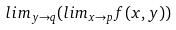<formula> <loc_0><loc_0><loc_500><loc_500>l i m _ { y \rightarrow q } ( l i m _ { x \rightarrow p } f ( x , y ) )</formula> 